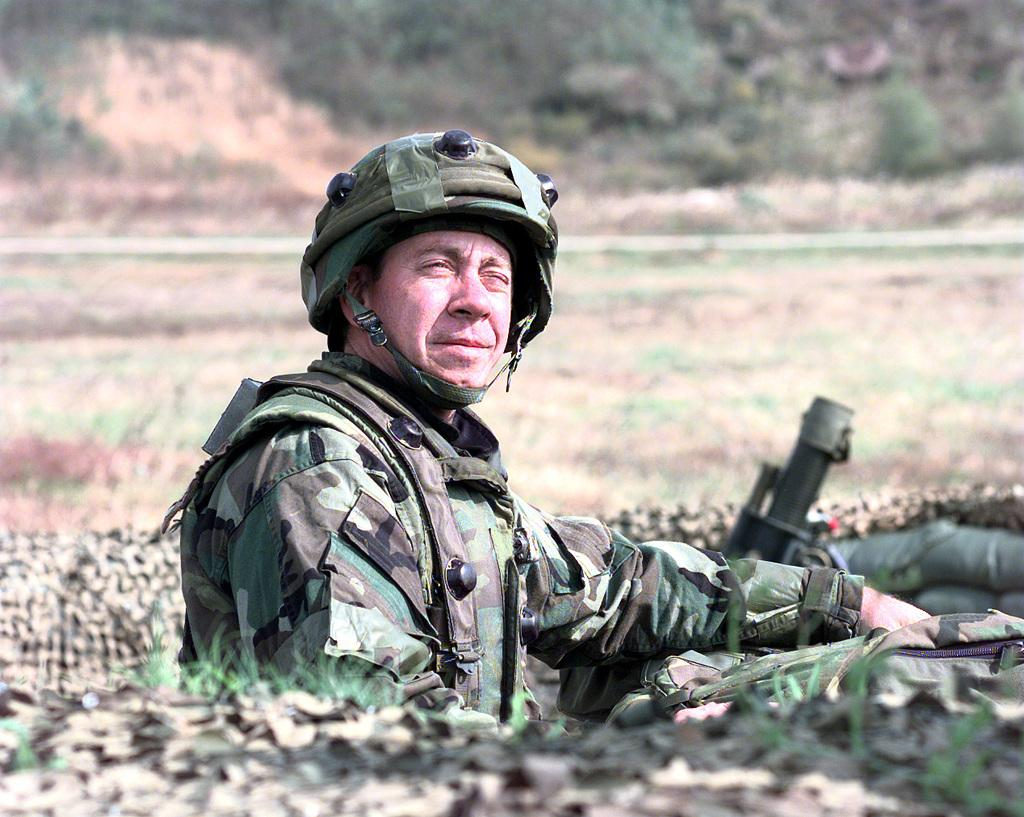What is the main subject of the image? There is a man in the image. What type of clothing is the man wearing? The man is wearing an army dress. What type of headgear is the man wearing? The man is wearing a helmet. What object is beside the man? There is a weapon beside the man. What can be seen in the background of the image? There are plants and grass on the ground in the background of the image. What type of whip is the man using to reason with the plants in the image? There is no whip present in the image, and the man is not interacting with the plants. 